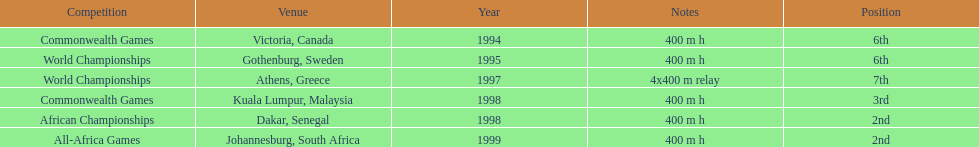Where was the next venue after athens, greece? Kuala Lumpur, Malaysia. 